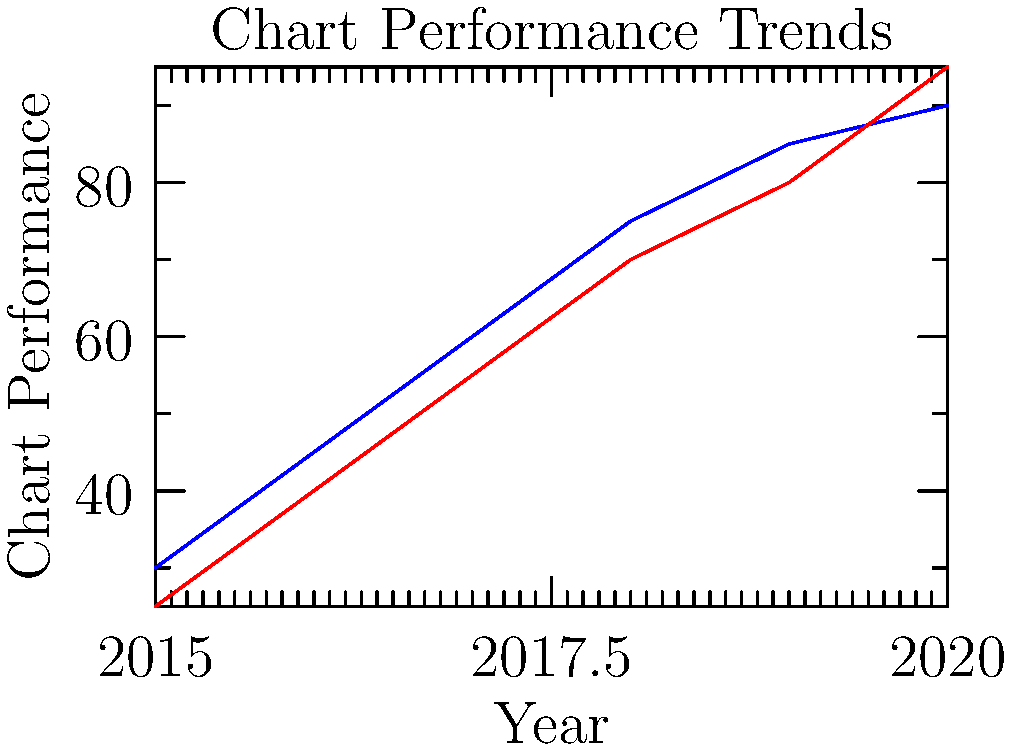Based on the line graph showing the chart performance trends of Wizkid and Davido from 2015 to 2020, in which year did Davido's performance surpass Wizkid's for the first time? To determine when Davido's performance surpassed Wizkid's, we need to analyze the graph year by year:

1. In 2015, Wizkid's performance (30) was higher than Davido's (25).
2. In 2016, Wizkid (45) was still higher than Davido (40).
3. In 2017, Wizkid (60) remained above Davido (55).
4. In 2018, Wizkid (75) continued to lead Davido (70).
5. In 2019, Wizkid (85) maintained his lead over Davido (80).
6. In 2020, Davido's performance (95) finally surpassed Wizkid's (90) for the first time.

The lines representing Wizkid and Davido intersect between 2019 and 2020, with Davido's line crossing above Wizkid's. This intersection point represents the moment when Davido's chart performance exceeded Wizkid's for the first time in the given period.
Answer: 2020 